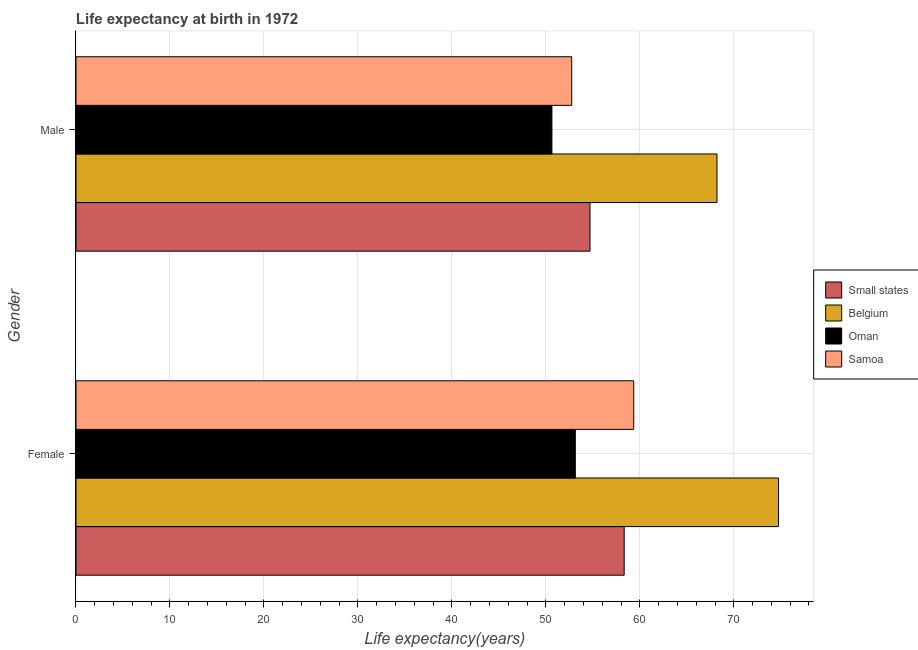Are the number of bars per tick equal to the number of legend labels?
Keep it short and to the point. Yes. How many bars are there on the 1st tick from the top?
Provide a short and direct response. 4. How many bars are there on the 2nd tick from the bottom?
Offer a terse response. 4. What is the label of the 1st group of bars from the top?
Provide a short and direct response. Male. What is the life expectancy(female) in Samoa?
Keep it short and to the point. 59.35. Across all countries, what is the maximum life expectancy(female)?
Offer a very short reply. 74.76. Across all countries, what is the minimum life expectancy(female)?
Ensure brevity in your answer.  53.13. In which country was the life expectancy(male) maximum?
Provide a succinct answer. Belgium. In which country was the life expectancy(male) minimum?
Your answer should be compact. Oman. What is the total life expectancy(female) in the graph?
Ensure brevity in your answer.  245.58. What is the difference between the life expectancy(female) in Samoa and that in Belgium?
Provide a short and direct response. -15.41. What is the difference between the life expectancy(female) in Small states and the life expectancy(male) in Belgium?
Your answer should be very brief. -9.87. What is the average life expectancy(female) per country?
Offer a very short reply. 61.4. What is the difference between the life expectancy(female) and life expectancy(male) in Belgium?
Keep it short and to the point. 6.55. In how many countries, is the life expectancy(female) greater than 52 years?
Offer a very short reply. 4. What is the ratio of the life expectancy(male) in Oman to that in Samoa?
Offer a terse response. 0.96. What does the 1st bar from the top in Female represents?
Offer a terse response. Samoa. What does the 2nd bar from the bottom in Male represents?
Ensure brevity in your answer.  Belgium. Are all the bars in the graph horizontal?
Your answer should be very brief. Yes. What is the difference between two consecutive major ticks on the X-axis?
Provide a short and direct response. 10. Does the graph contain any zero values?
Give a very brief answer. No. Does the graph contain grids?
Give a very brief answer. Yes. How are the legend labels stacked?
Offer a terse response. Vertical. What is the title of the graph?
Make the answer very short. Life expectancy at birth in 1972. What is the label or title of the X-axis?
Give a very brief answer. Life expectancy(years). What is the label or title of the Y-axis?
Your response must be concise. Gender. What is the Life expectancy(years) in Small states in Female?
Your answer should be compact. 58.34. What is the Life expectancy(years) in Belgium in Female?
Your response must be concise. 74.76. What is the Life expectancy(years) of Oman in Female?
Offer a terse response. 53.13. What is the Life expectancy(years) of Samoa in Female?
Offer a very short reply. 59.35. What is the Life expectancy(years) of Small states in Male?
Keep it short and to the point. 54.7. What is the Life expectancy(years) of Belgium in Male?
Offer a terse response. 68.21. What is the Life expectancy(years) of Oman in Male?
Provide a short and direct response. 50.65. What is the Life expectancy(years) in Samoa in Male?
Your response must be concise. 52.75. Across all Gender, what is the maximum Life expectancy(years) in Small states?
Your response must be concise. 58.34. Across all Gender, what is the maximum Life expectancy(years) in Belgium?
Your answer should be very brief. 74.76. Across all Gender, what is the maximum Life expectancy(years) in Oman?
Provide a succinct answer. 53.13. Across all Gender, what is the maximum Life expectancy(years) in Samoa?
Give a very brief answer. 59.35. Across all Gender, what is the minimum Life expectancy(years) of Small states?
Keep it short and to the point. 54.7. Across all Gender, what is the minimum Life expectancy(years) in Belgium?
Offer a terse response. 68.21. Across all Gender, what is the minimum Life expectancy(years) of Oman?
Give a very brief answer. 50.65. Across all Gender, what is the minimum Life expectancy(years) in Samoa?
Make the answer very short. 52.75. What is the total Life expectancy(years) of Small states in the graph?
Keep it short and to the point. 113.03. What is the total Life expectancy(years) of Belgium in the graph?
Ensure brevity in your answer.  142.97. What is the total Life expectancy(years) of Oman in the graph?
Provide a short and direct response. 103.78. What is the total Life expectancy(years) of Samoa in the graph?
Give a very brief answer. 112.1. What is the difference between the Life expectancy(years) of Small states in Female and that in Male?
Your answer should be very brief. 3.64. What is the difference between the Life expectancy(years) of Belgium in Female and that in Male?
Provide a succinct answer. 6.55. What is the difference between the Life expectancy(years) in Oman in Female and that in Male?
Provide a succinct answer. 2.49. What is the difference between the Life expectancy(years) in Samoa in Female and that in Male?
Give a very brief answer. 6.6. What is the difference between the Life expectancy(years) of Small states in Female and the Life expectancy(years) of Belgium in Male?
Provide a short and direct response. -9.87. What is the difference between the Life expectancy(years) of Small states in Female and the Life expectancy(years) of Oman in Male?
Your answer should be compact. 7.69. What is the difference between the Life expectancy(years) in Small states in Female and the Life expectancy(years) in Samoa in Male?
Your response must be concise. 5.59. What is the difference between the Life expectancy(years) of Belgium in Female and the Life expectancy(years) of Oman in Male?
Your answer should be compact. 24.11. What is the difference between the Life expectancy(years) of Belgium in Female and the Life expectancy(years) of Samoa in Male?
Your answer should be compact. 22.01. What is the difference between the Life expectancy(years) in Oman in Female and the Life expectancy(years) in Samoa in Male?
Your response must be concise. 0.39. What is the average Life expectancy(years) in Small states per Gender?
Provide a short and direct response. 56.52. What is the average Life expectancy(years) in Belgium per Gender?
Offer a terse response. 71.48. What is the average Life expectancy(years) of Oman per Gender?
Your answer should be very brief. 51.89. What is the average Life expectancy(years) in Samoa per Gender?
Offer a very short reply. 56.05. What is the difference between the Life expectancy(years) of Small states and Life expectancy(years) of Belgium in Female?
Your response must be concise. -16.42. What is the difference between the Life expectancy(years) in Small states and Life expectancy(years) in Oman in Female?
Make the answer very short. 5.2. What is the difference between the Life expectancy(years) in Small states and Life expectancy(years) in Samoa in Female?
Keep it short and to the point. -1.01. What is the difference between the Life expectancy(years) in Belgium and Life expectancy(years) in Oman in Female?
Your answer should be compact. 21.62. What is the difference between the Life expectancy(years) of Belgium and Life expectancy(years) of Samoa in Female?
Offer a very short reply. 15.41. What is the difference between the Life expectancy(years) of Oman and Life expectancy(years) of Samoa in Female?
Keep it short and to the point. -6.21. What is the difference between the Life expectancy(years) in Small states and Life expectancy(years) in Belgium in Male?
Your response must be concise. -13.51. What is the difference between the Life expectancy(years) of Small states and Life expectancy(years) of Oman in Male?
Ensure brevity in your answer.  4.05. What is the difference between the Life expectancy(years) of Small states and Life expectancy(years) of Samoa in Male?
Make the answer very short. 1.95. What is the difference between the Life expectancy(years) in Belgium and Life expectancy(years) in Oman in Male?
Provide a succinct answer. 17.57. What is the difference between the Life expectancy(years) in Belgium and Life expectancy(years) in Samoa in Male?
Make the answer very short. 15.46. What is the difference between the Life expectancy(years) in Oman and Life expectancy(years) in Samoa in Male?
Your answer should be very brief. -2.1. What is the ratio of the Life expectancy(years) in Small states in Female to that in Male?
Provide a short and direct response. 1.07. What is the ratio of the Life expectancy(years) of Belgium in Female to that in Male?
Keep it short and to the point. 1.1. What is the ratio of the Life expectancy(years) in Oman in Female to that in Male?
Make the answer very short. 1.05. What is the ratio of the Life expectancy(years) in Samoa in Female to that in Male?
Provide a short and direct response. 1.13. What is the difference between the highest and the second highest Life expectancy(years) of Small states?
Your answer should be very brief. 3.64. What is the difference between the highest and the second highest Life expectancy(years) in Belgium?
Offer a very short reply. 6.55. What is the difference between the highest and the second highest Life expectancy(years) of Oman?
Offer a very short reply. 2.49. What is the difference between the highest and the second highest Life expectancy(years) of Samoa?
Keep it short and to the point. 6.6. What is the difference between the highest and the lowest Life expectancy(years) of Small states?
Make the answer very short. 3.64. What is the difference between the highest and the lowest Life expectancy(years) of Belgium?
Give a very brief answer. 6.55. What is the difference between the highest and the lowest Life expectancy(years) in Oman?
Make the answer very short. 2.49. What is the difference between the highest and the lowest Life expectancy(years) of Samoa?
Provide a succinct answer. 6.6. 